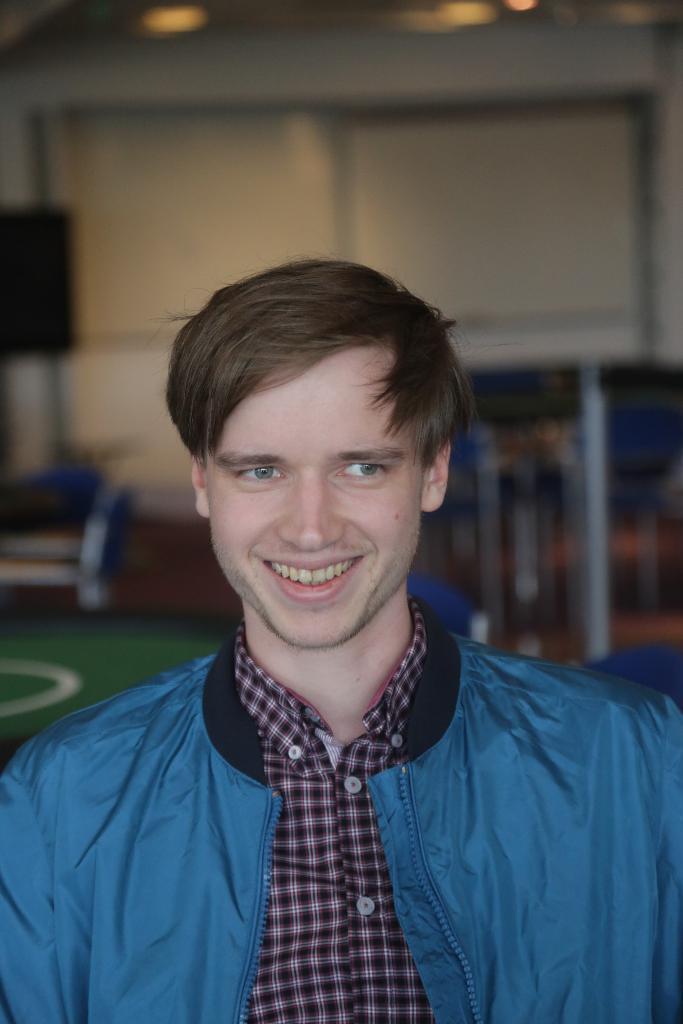In one or two sentences, can you explain what this image depicts? In this picture there is a man standing and smiling. At the back there is a speaker and there are objects and their might be a board. At the top there are lights. At the bottom there is a floor. 